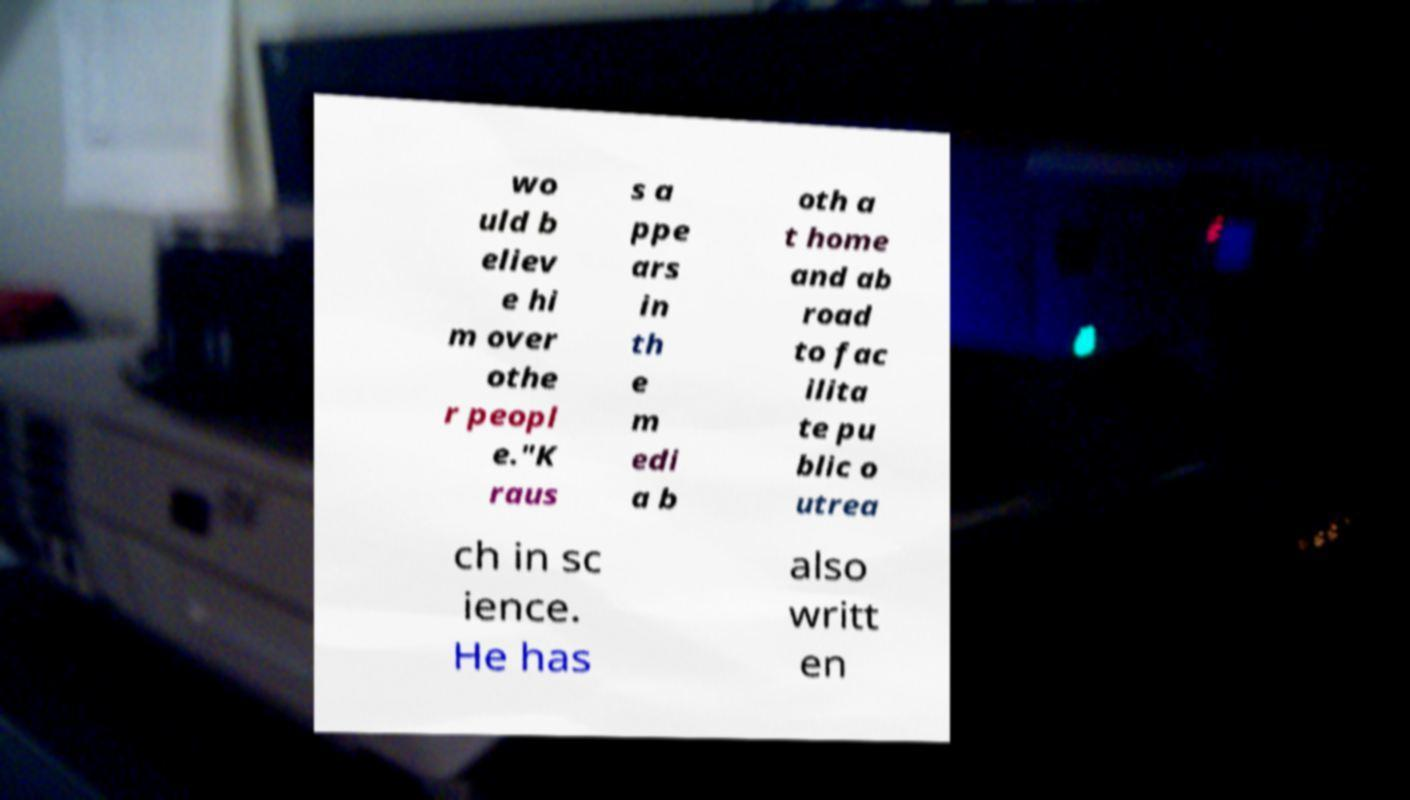Could you assist in decoding the text presented in this image and type it out clearly? wo uld b eliev e hi m over othe r peopl e."K raus s a ppe ars in th e m edi a b oth a t home and ab road to fac ilita te pu blic o utrea ch in sc ience. He has also writt en 